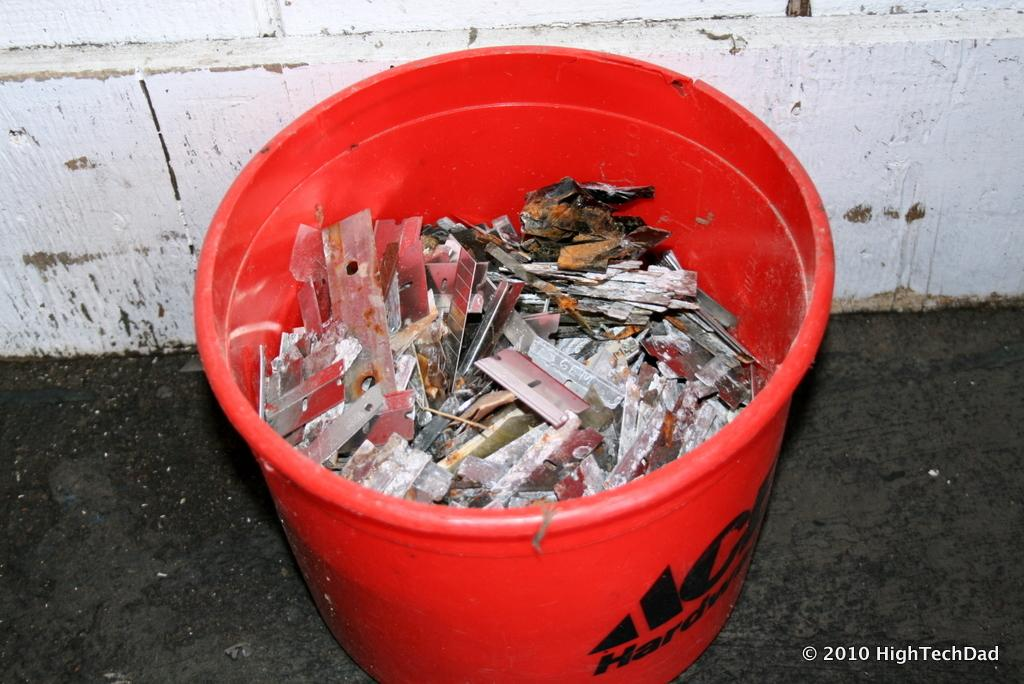<image>
Give a short and clear explanation of the subsequent image. A red Ace Hardware bucket is full of used razor blades and debris. 